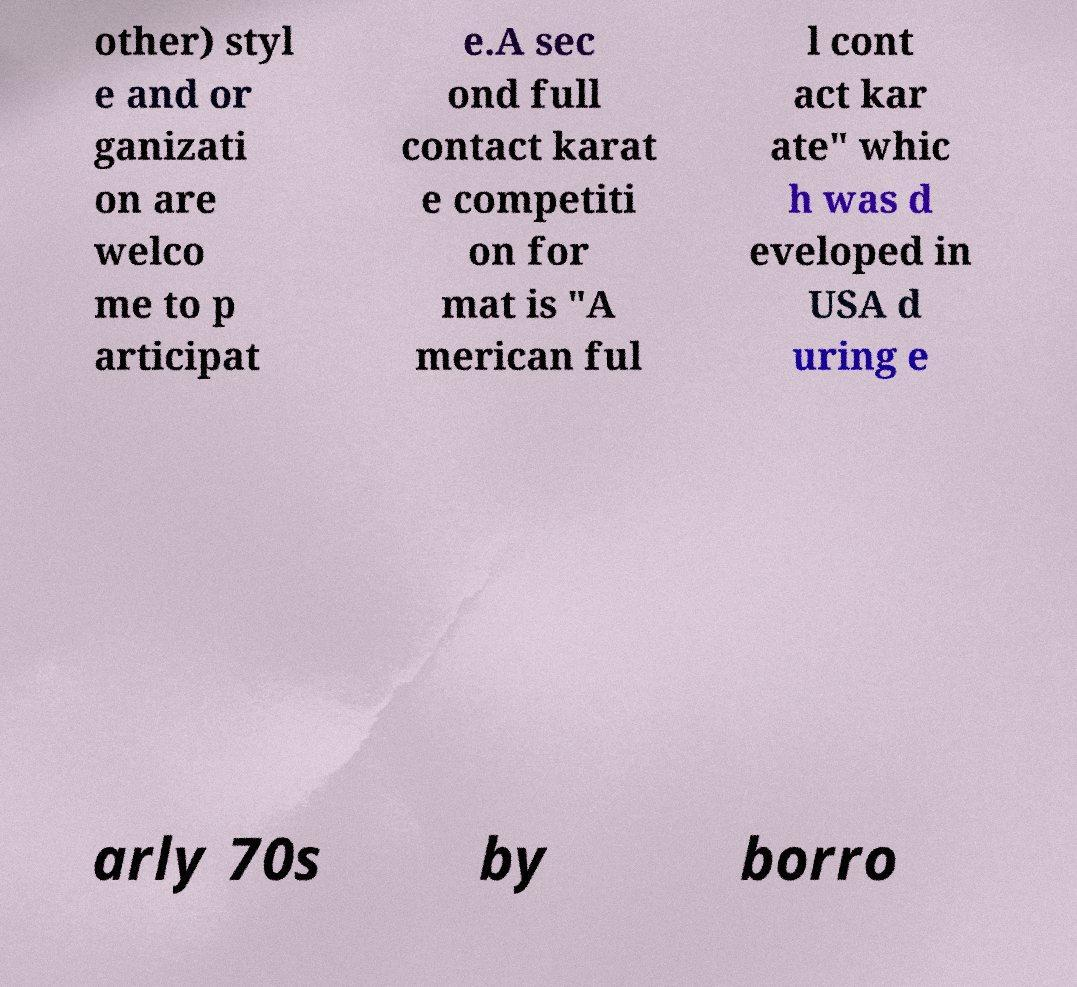Please read and relay the text visible in this image. What does it say? other) styl e and or ganizati on are welco me to p articipat e.A sec ond full contact karat e competiti on for mat is "A merican ful l cont act kar ate" whic h was d eveloped in USA d uring e arly 70s by borro 